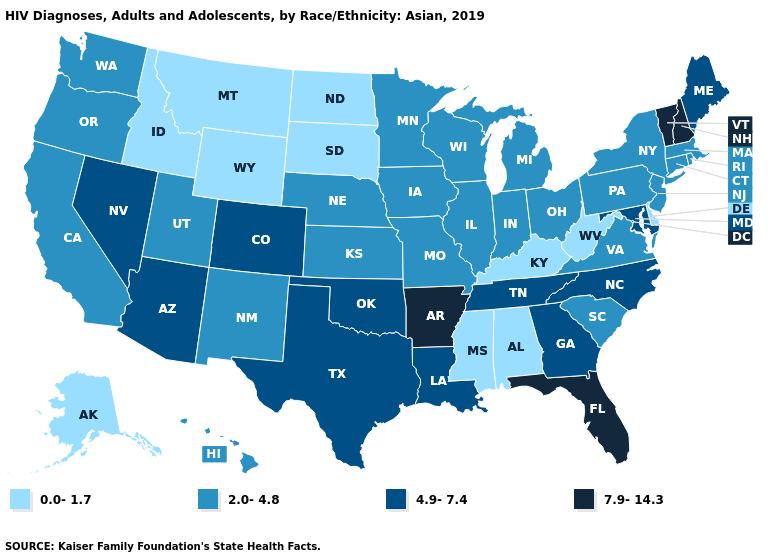Name the states that have a value in the range 4.9-7.4?
Be succinct. Arizona, Colorado, Georgia, Louisiana, Maine, Maryland, Nevada, North Carolina, Oklahoma, Tennessee, Texas. Does the map have missing data?
Short answer required. No. Among the states that border Texas , does Arkansas have the highest value?
Short answer required. Yes. What is the highest value in the MidWest ?
Be succinct. 2.0-4.8. Name the states that have a value in the range 0.0-1.7?
Give a very brief answer. Alabama, Alaska, Delaware, Idaho, Kentucky, Mississippi, Montana, North Dakota, South Dakota, West Virginia, Wyoming. What is the highest value in the USA?
Answer briefly. 7.9-14.3. Among the states that border Idaho , does Oregon have the highest value?
Answer briefly. No. Which states have the highest value in the USA?
Be succinct. Arkansas, Florida, New Hampshire, Vermont. What is the value of Minnesota?
Concise answer only. 2.0-4.8. Among the states that border Indiana , which have the highest value?
Answer briefly. Illinois, Michigan, Ohio. What is the highest value in states that border Nebraska?
Give a very brief answer. 4.9-7.4. Is the legend a continuous bar?
Answer briefly. No. Name the states that have a value in the range 0.0-1.7?
Give a very brief answer. Alabama, Alaska, Delaware, Idaho, Kentucky, Mississippi, Montana, North Dakota, South Dakota, West Virginia, Wyoming. Does North Dakota have a lower value than Idaho?
Quick response, please. No. Does Alabama have the same value as West Virginia?
Be succinct. Yes. 